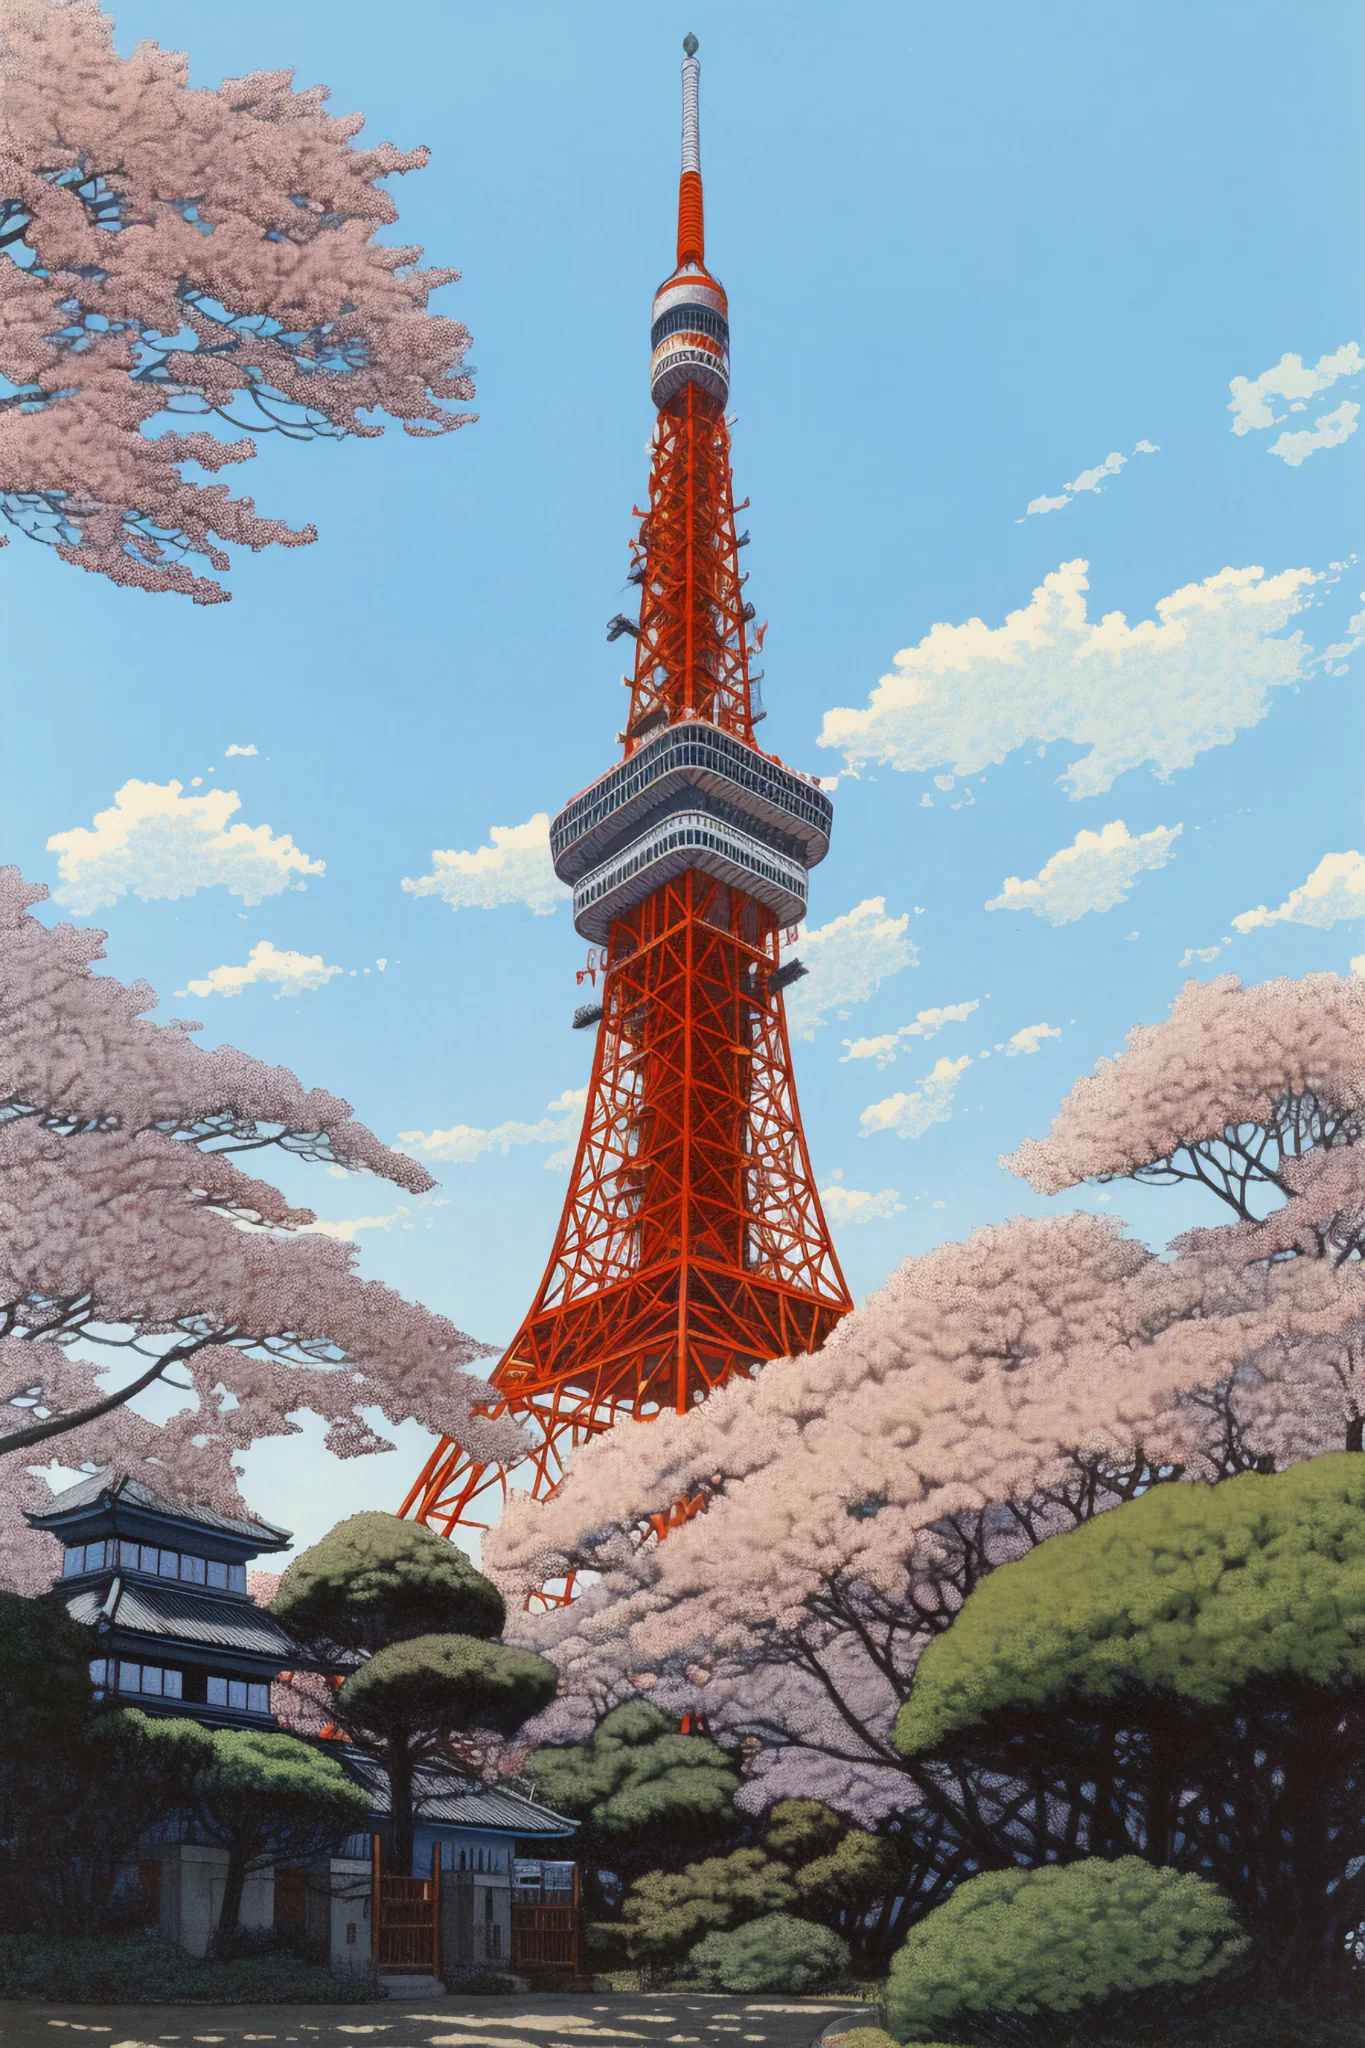If someone were to propose marriage here, what might the perfect setup look like? For a perfect marriage proposal at Tokyo Tower during cherry blossom season, the setup would be nothing short of magical. Imagine a quiet corner under a canopy of blooming sakura trees, fairy lights twinkling in the branches as evening falls. A path lined with rose petals leads to a small clearing with a view of the tower, now bathed in the soft glow of twilight. As the couple reaches this spot, a favorite song plays softly in the background. Amid the romantic setting, with the tower as a majestic backdrop, the moment of the proposal is captured forever in the embrace of nature's beauty and urban grandeur. 